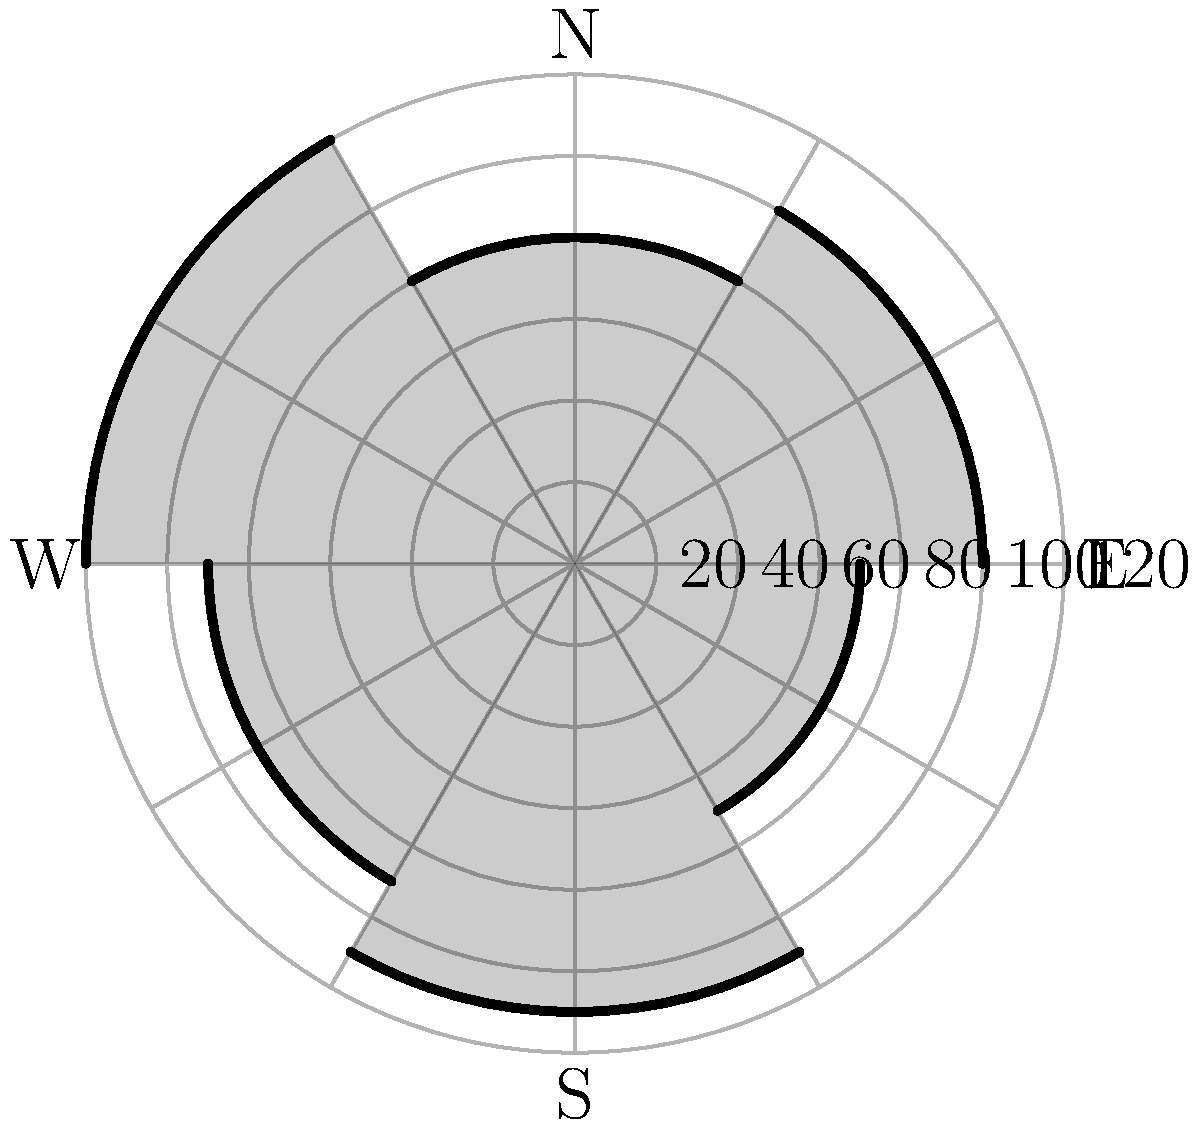In the radar coverage diagram for a post-war air defense system, which sector has the longest range, and what is its approximate coverage in kilometers? To answer this question, we need to analyze the radar coverage diagram:

1. The diagram shows six sectors of radar coverage in a polar coordinate system.
2. Each sector represents a different direction and range of coverage.
3. The concentric circles represent the range in kilometers, with each circle representing 20 km.
4. We need to identify the sector that extends the furthest from the center.

Analyzing each sector clockwise:
- Sector 1 (0° to 60°): Extends to the 5th circle (100 km)
- Sector 2 (60° to 120°): Extends to the 4th circle (80 km)
- Sector 3 (120° to 180°): Extends to the 6th circle (120 km)
- Sector 4 (180° to 240°): Extends to between the 4th and 5th circles (90 km)
- Sector 5 (240° to 300°): Extends to between the 5th and 6th circles (110 km)
- Sector 6 (300° to 360°): Extends to between the 3rd and 4th circles (70 km)

The sector with the longest range is Sector 3, covering the southeast direction (120° to 180°). It extends to the 6th circle, which represents 120 km.
Answer: Southeast sector, 120 km 